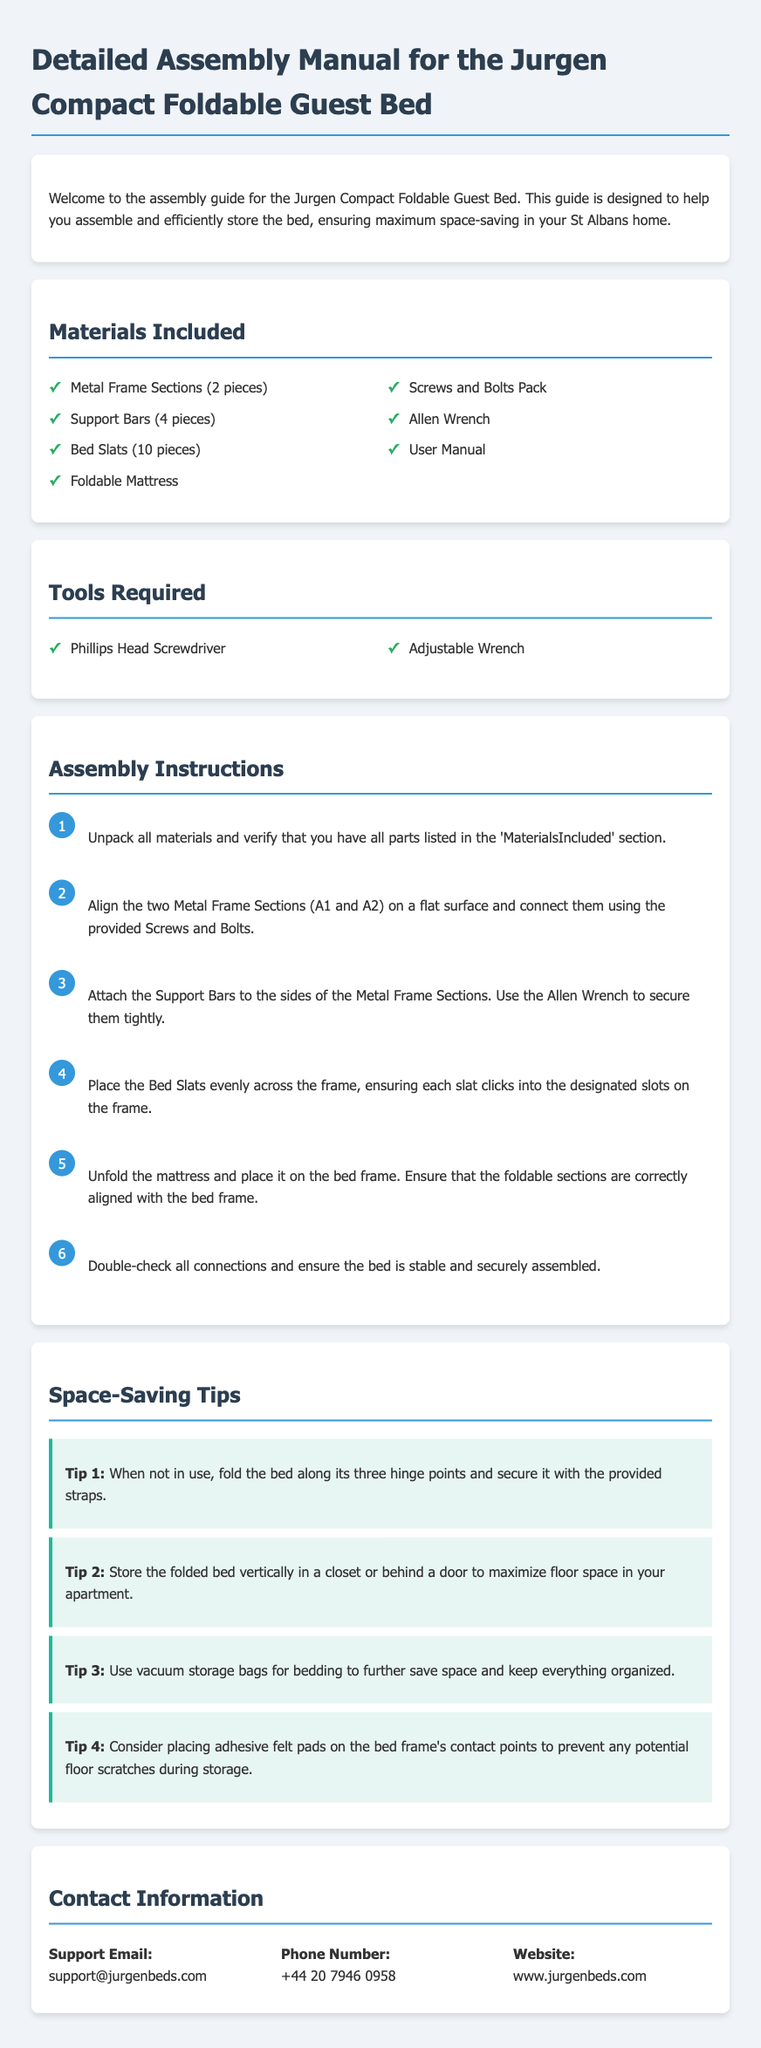what is the title of the document? The title of the document is specified at the top as "Detailed Assembly Manual for the Jurgen Compact Foldable Guest Bed."
Answer: Detailed Assembly Manual for the Jurgen Compact Foldable Guest Bed how many Bed Slats are included? The document lists a total of 10 Bed Slats included in the materials.
Answer: 10 what is the first step in the assembly instructions? The first step described in the assembly instructions is to unpack all materials and verify the parts.
Answer: Unpack all materials and verify that you have all parts listed in the 'Materials Included' section how should the bed be stored when not in use? The document advises that the bed should be folded along its three hinge points and secured with provided straps when not in use.
Answer: Fold the bed along its three hinge points and secure it with the provided straps what tools are required for assembly? The required tools for assembly listed in the document are a Phillips Head Screwdriver and an Adjustable Wrench.
Answer: Phillips Head Screwdriver, Adjustable Wrench how many support bars are mentioned in the materials? The document mentions that there are 4 Support Bars included in the materials.
Answer: 4 what is suggested to prevent floor scratches? The document suggests placing adhesive felt pads on the bed frame's contact points to prevent floor scratches during storage.
Answer: Adhesive felt pads what is the support email provided? The support email provided in the contact information is support@jurgenbeds.com.
Answer: support@jurgenbeds.com how many assembly steps are there in total? The assembly instructions detail a total of 6 steps for assembling the bed.
Answer: 6 